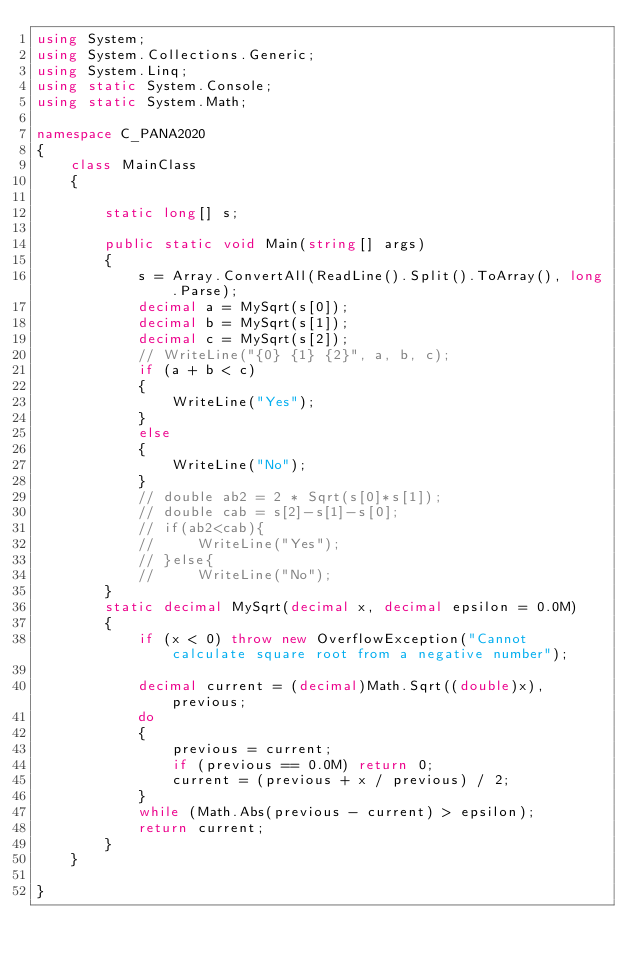<code> <loc_0><loc_0><loc_500><loc_500><_C#_>using System;
using System.Collections.Generic;
using System.Linq;
using static System.Console;
using static System.Math;

namespace C_PANA2020
{
    class MainClass
    {

        static long[] s;

        public static void Main(string[] args)
        {
            s = Array.ConvertAll(ReadLine().Split().ToArray(), long.Parse);
            decimal a = MySqrt(s[0]);
            decimal b = MySqrt(s[1]);
            decimal c = MySqrt(s[2]);
            // WriteLine("{0} {1} {2}", a, b, c);
            if (a + b < c)
            {
                WriteLine("Yes");
            }
            else
            {
                WriteLine("No");
            }
            // double ab2 = 2 * Sqrt(s[0]*s[1]);
            // double cab = s[2]-s[1]-s[0];
            // if(ab2<cab){
            //     WriteLine("Yes");
            // }else{
            //     WriteLine("No");
        }
        static decimal MySqrt(decimal x, decimal epsilon = 0.0M)
        {
            if (x < 0) throw new OverflowException("Cannot calculate square root from a negative number");

            decimal current = (decimal)Math.Sqrt((double)x), previous;
            do
            {
                previous = current;
                if (previous == 0.0M) return 0;
                current = (previous + x / previous) / 2;
            }
            while (Math.Abs(previous - current) > epsilon);
            return current;
        }
    }

}
</code> 